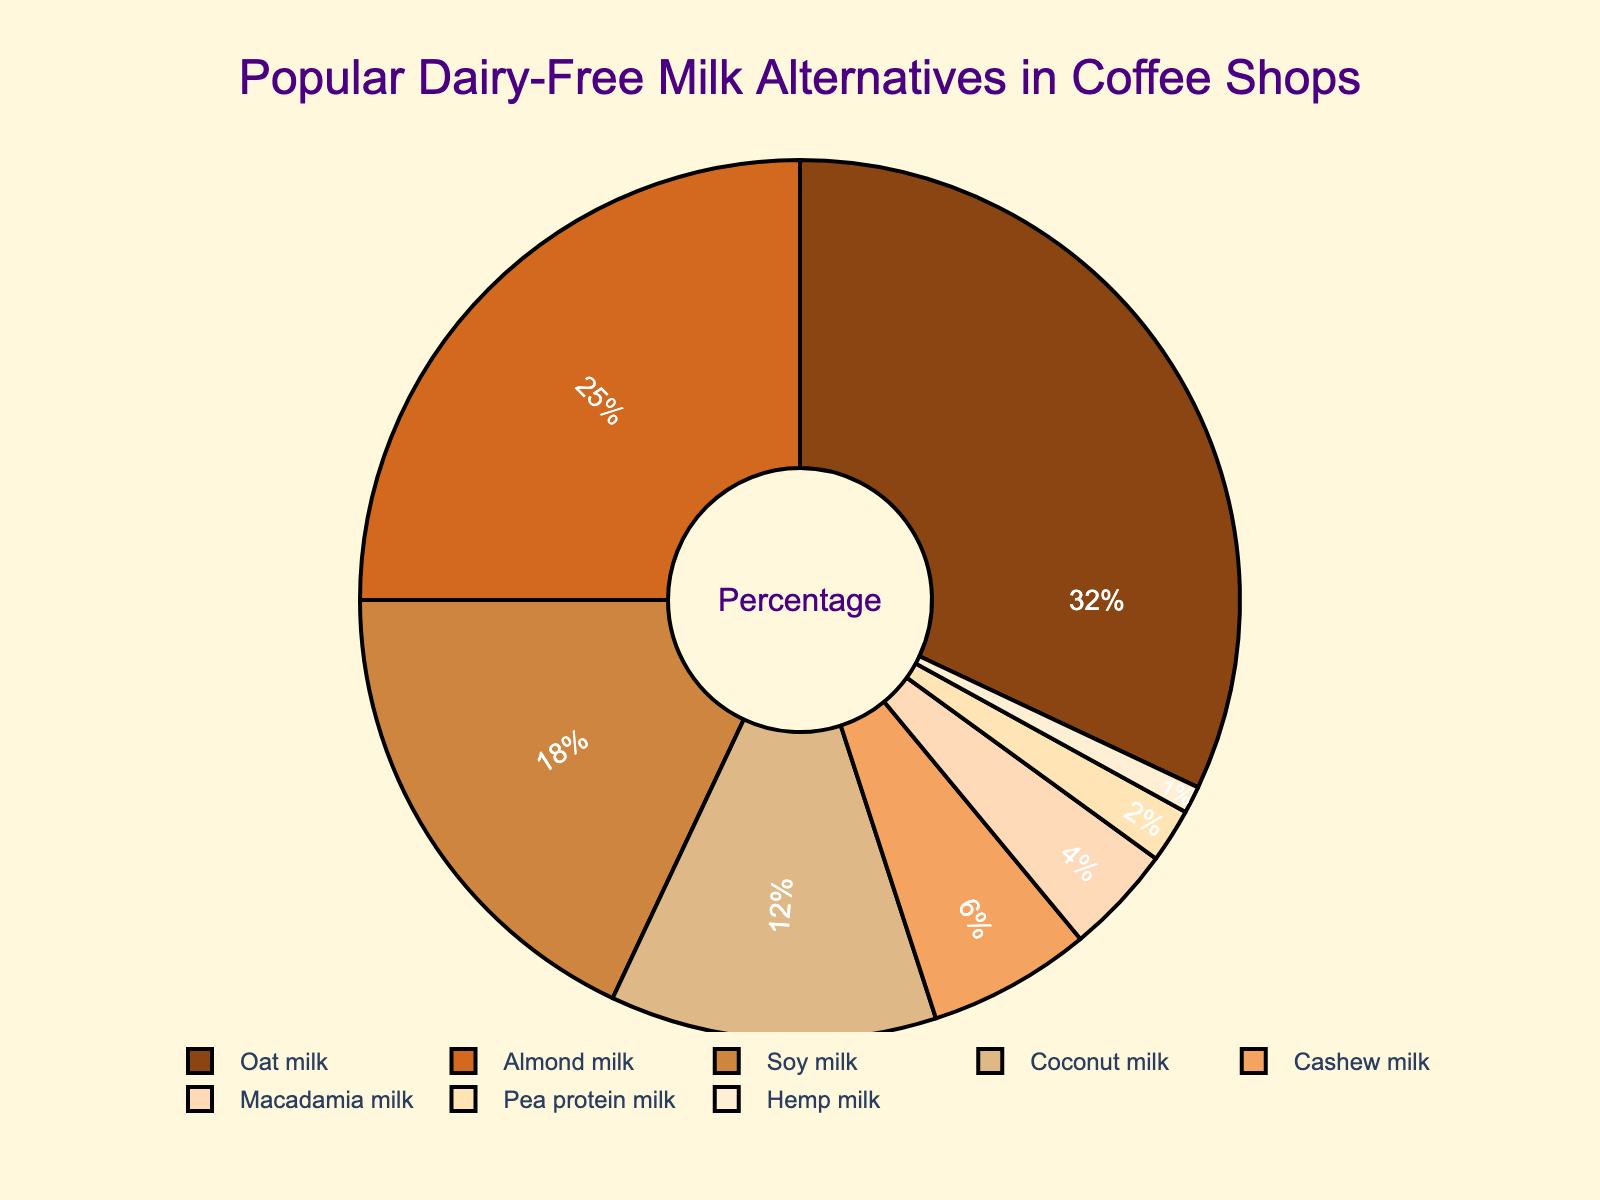What is the most popular dairy-free milk alternative? The pie chart shows the portion sizes, and the largest segment represents Oat milk, indicating it has the highest percentage.
Answer: Oat milk What is the percentage difference between Oat milk and Almond milk? Oat milk has a percentage of 32% and Almond milk has 25%. The difference is calculated by subtracting 25 from 32.
Answer: 7% How many types of dairy-free milk alternatives have a percentage greater than 10%? Summing the percentages, Oat milk (32%), Almond milk (25%), Soy milk (18%), and Coconut milk (12%) all are greater than 10%.
Answer: 4 Which dairy-free milk alternatives make up less than 5% of the total? The pie chart shows Cashew milk at 6%, Macadamia milk at 4%, Pea protein milk at 2%, and Hemp milk at 1%. Selecting those less than 5% gives us Macadamia, Pea protein, and Hemp.
Answer: Macadamia milk, Pea protein milk, Hemp milk Is Soy milk used more frequently than Coconut milk? By looking at the pie chart, we see that Soy milk makes up 18% while Coconut milk makes up 12%. Hence, Soy milk is used more frequently.
Answer: Yes What is the total percentage of the top three most popular dairy-free milk alternatives? The top three in the chart are Oat milk (32%), Almond milk (25%), and Soy milk (18%). Their total percentage is 32 + 25 + 18.
Answer: 75% Are there any alternatives with a percentage exactly equal to half of Oat milk's percentage? Half of Oat milk's percentage (32%) is 16%. Looking at the pie chart, none of the alternatives have a percentage of 16%.
Answer: No How much more popular is Oat milk than the least popular milk alternative? The least popular alternative is Hemp milk with 1%. Oat milk is 32%, so the difference is 32 - 1.
Answer: 31% Which color represents the largest segment in the pie chart? The largest segment corresponds to Oat milk, which is colored brown.
Answer: Brown What proportion of the total does Cashew and Macadamia milk comprise together? Cashew milk has 6% and Macadamia milk has 4%. Adding these together gives us 6 + 4.
Answer: 10% 